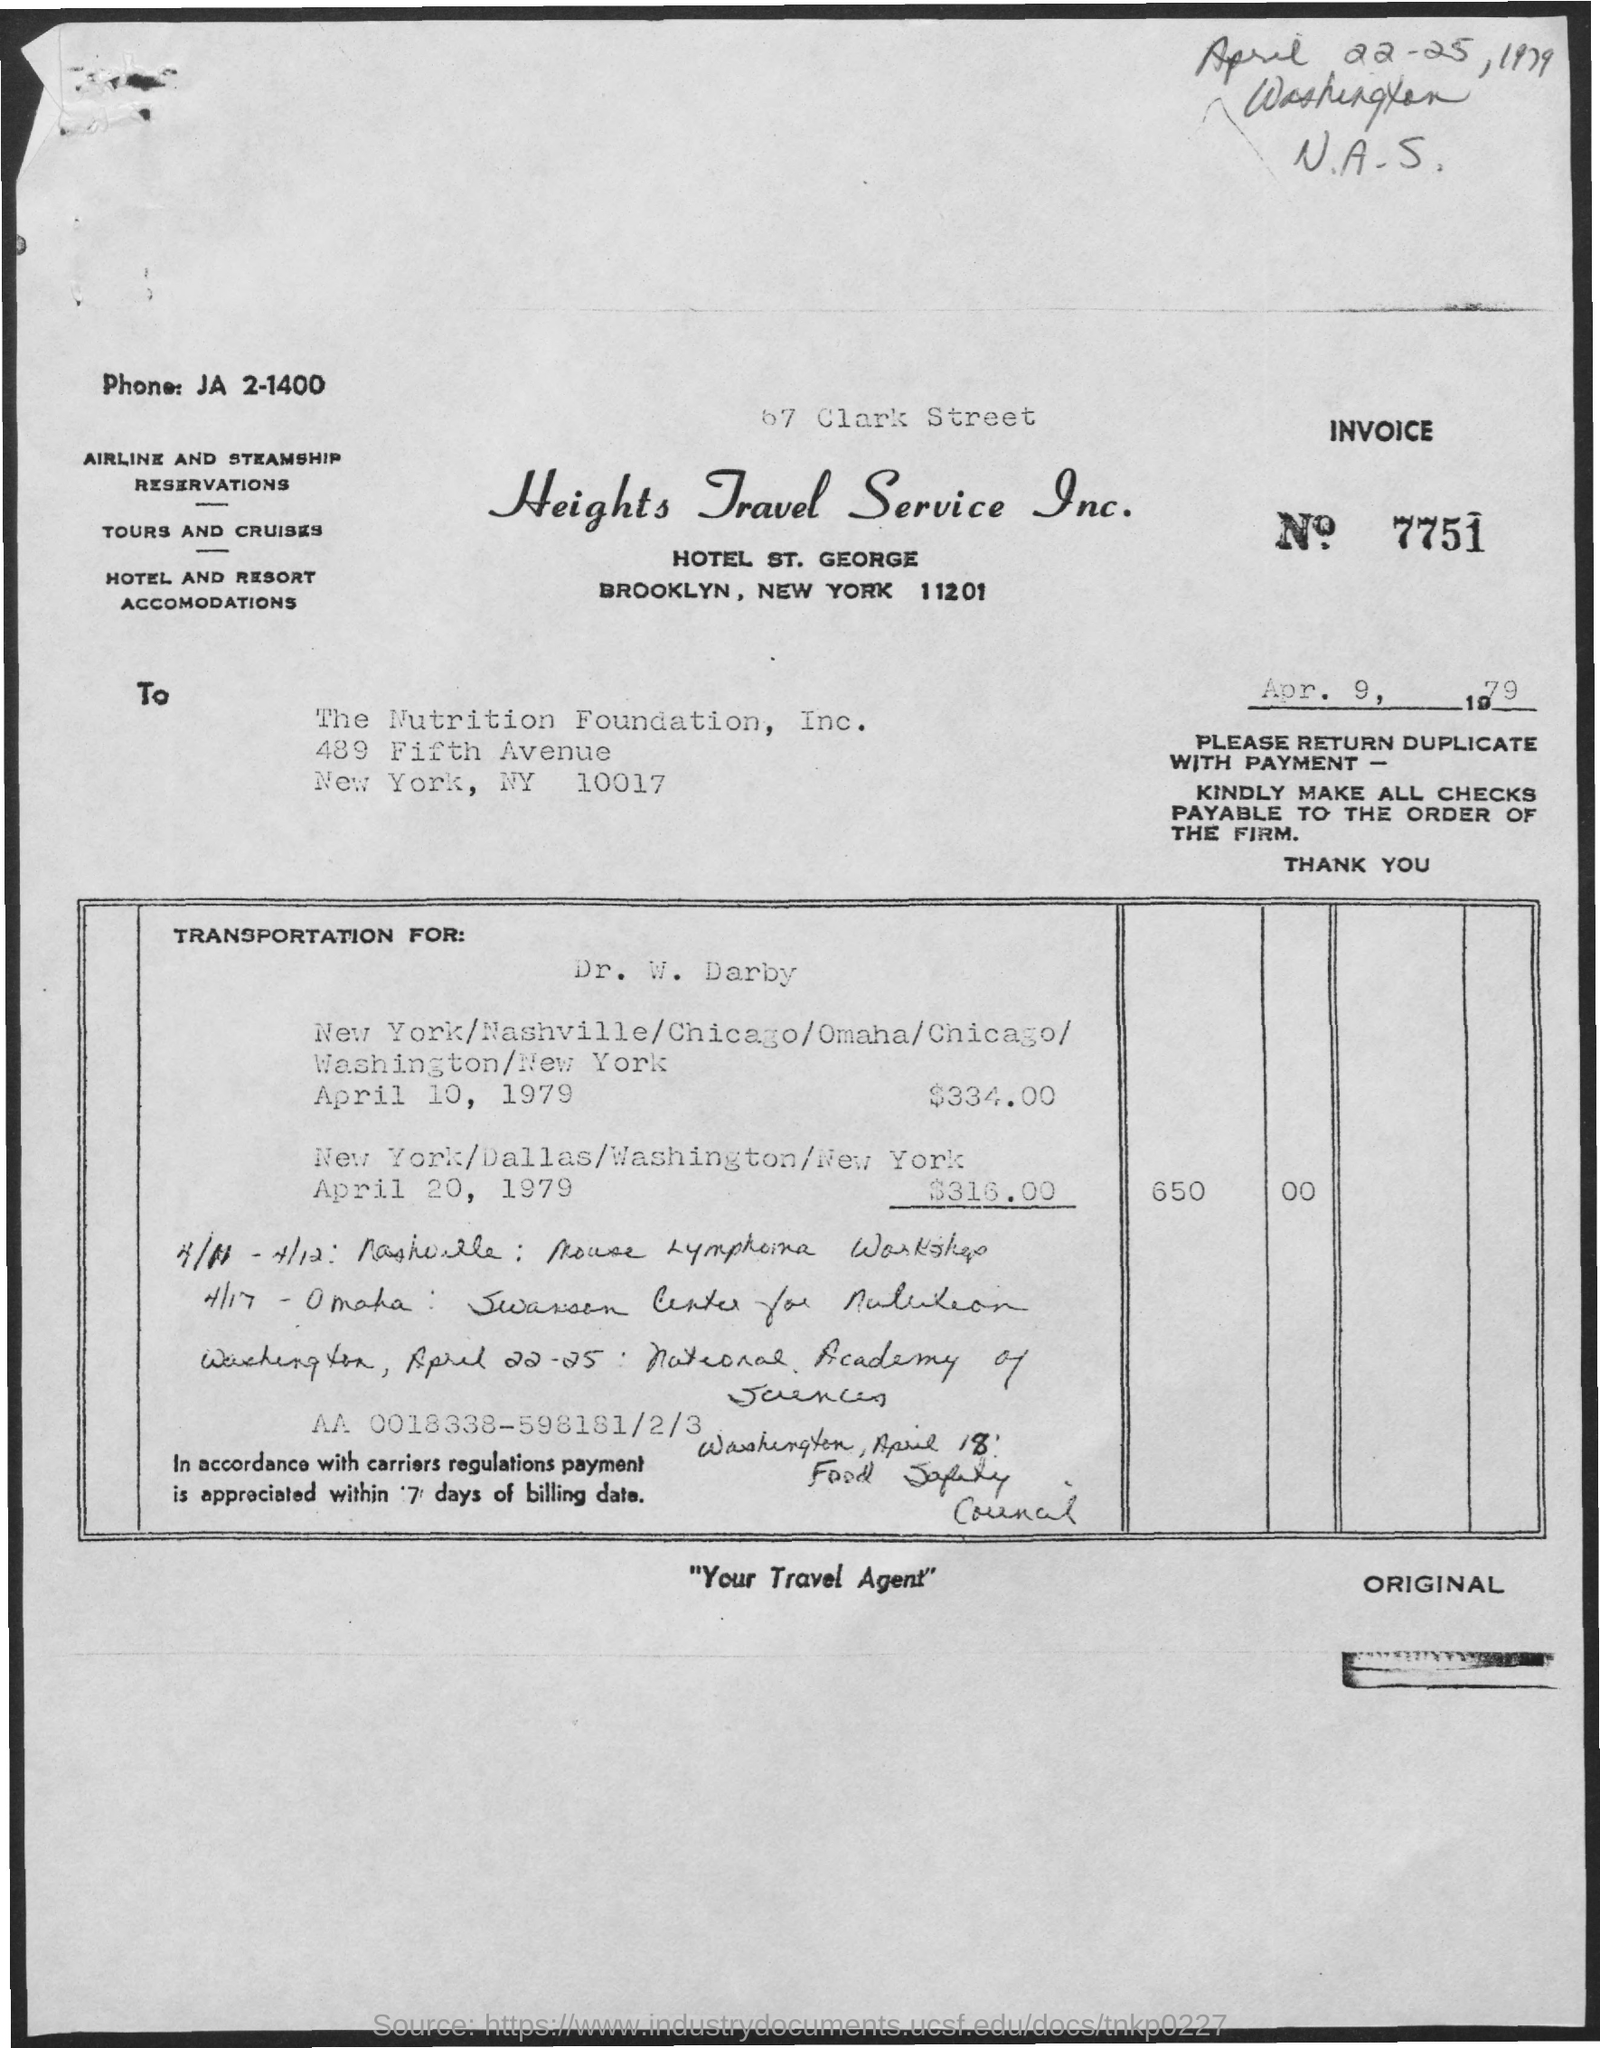What is the name of the travel service?
Ensure brevity in your answer.  Heights Travel Service Inc. 